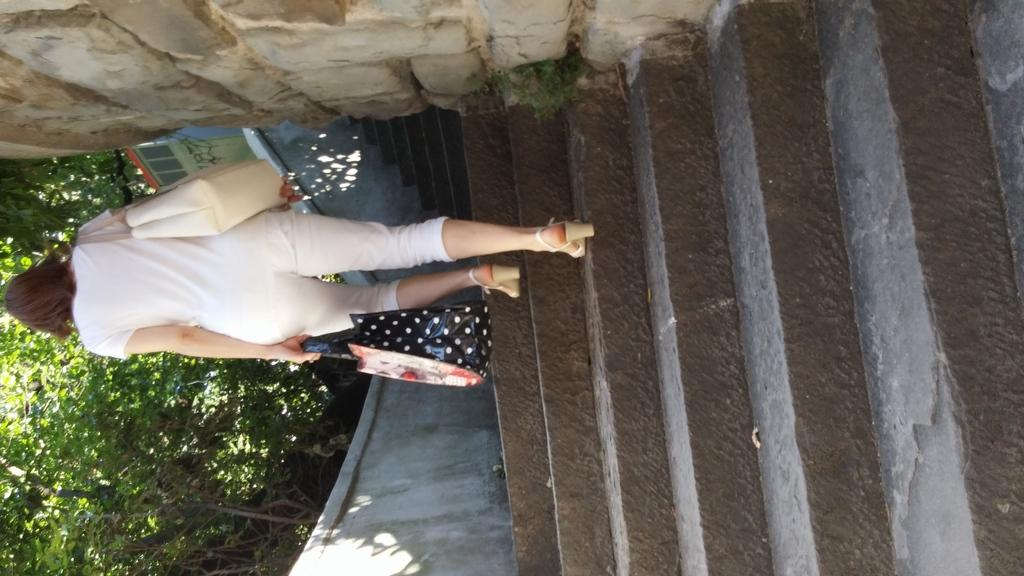Who is the main subject in the image? There is a woman in the image. What is the woman doing in the image? The woman is walking. What can be seen in the background of the image? There is a wall and trees in the background of the image. What type of ship can be seen sailing in the background of the image? There is no ship present in the image; it features a woman walking with a wall and trees in the background. How many beads are hanging from the woman's necklace in the image? There is no necklace or beads visible in the image. 